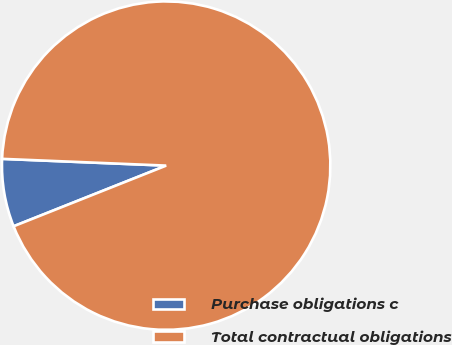Convert chart to OTSL. <chart><loc_0><loc_0><loc_500><loc_500><pie_chart><fcel>Purchase obligations c<fcel>Total contractual obligations<nl><fcel>6.68%<fcel>93.32%<nl></chart> 